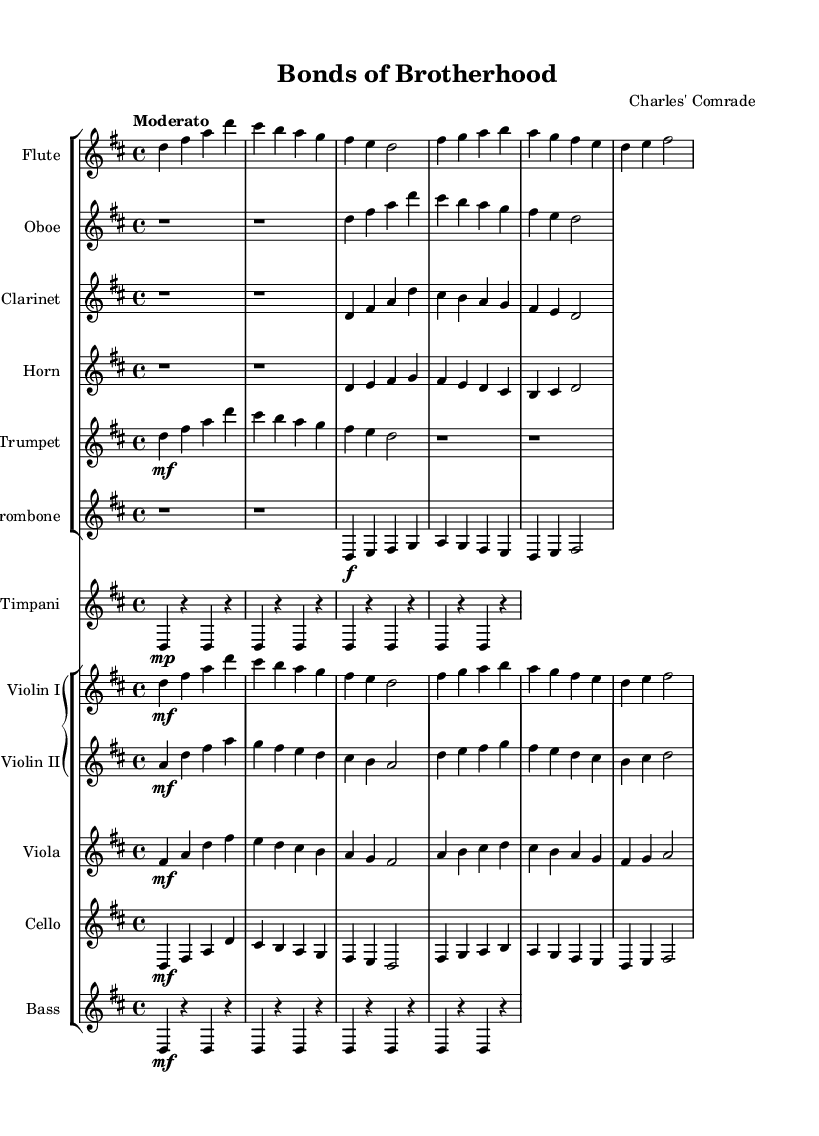What is the key signature of this music? The key signature indicates that there are two sharps, which corresponds to D major. We can find this by looking at the key signature indicated in the global block of the code, where it shows \key d \major.
Answer: D major What is the time signature of the piece? The time signature is 4/4, which is specified in the global section of the code as \time 4/4. This indicates that each measure contains four beats, and each quarter note receives one beat.
Answer: 4/4 What is the tempo marking for the piece? The tempo marking is "Moderato", as indicated in the global section of the code with the statement \tempo "Moderato". This term suggests a moderate pace for the performance of the piece.
Answer: Moderato How many instruments are featured in this symphony? The symphony features a total of 10 instruments: Flute, Oboe, Clarinet, Horn, Trumpet, Trombone, Timpani, Violin I, Violin II, Viola, Cello, and Bass. Counting each individual instrument listed in the score section confirms this total.
Answer: 10 Which instruments play the melody in the first section? The melody in the first section is primarily carried by the Flute, Violin I, and Violin II, which are the first instruments to present melodic lines in the score. This is determined by analyzing the notation in the score where these instruments have the most prominent and clear melodic lines.
Answer: Flute, Violin I, Violin II What dynamic markings are present in the piece? The piece contains various dynamic markings including "mf" (mezzo-forte) and "f" (forte), which indicate the level of loudness for specific phrases or sections in the music. These markings can be found throughout the score next to specific notes.
Answer: mf, f In what ways does this symphony explore leadership and camaraderie? The exploration of leadership and camaraderie is evident through the collaborative play among the instruments, where the exchange of melodic themes and harmonies creates a sense of unity and shared purpose. The score indicates overlapping and interdependent parts, suggesting a strong connection between the musicians reflecting these themes.
Answer: Unity, exchange 